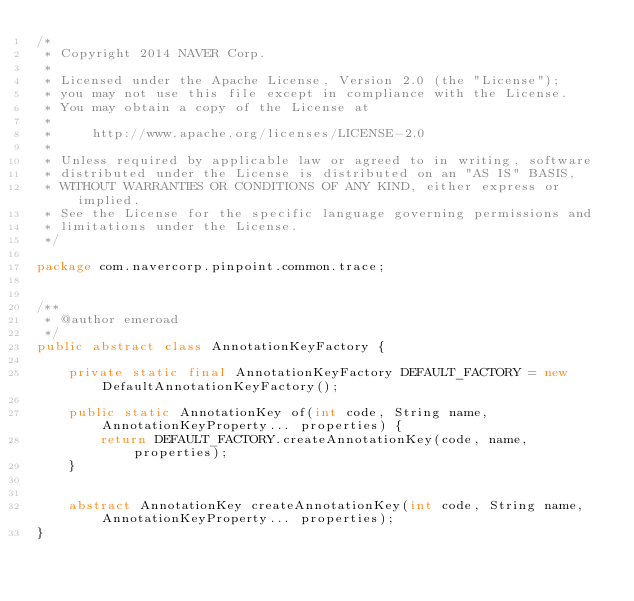Convert code to text. <code><loc_0><loc_0><loc_500><loc_500><_Java_>/*
 * Copyright 2014 NAVER Corp.
 *
 * Licensed under the Apache License, Version 2.0 (the "License");
 * you may not use this file except in compliance with the License.
 * You may obtain a copy of the License at
 *
 *     http://www.apache.org/licenses/LICENSE-2.0
 *
 * Unless required by applicable law or agreed to in writing, software
 * distributed under the License is distributed on an "AS IS" BASIS,
 * WITHOUT WARRANTIES OR CONDITIONS OF ANY KIND, either express or implied.
 * See the License for the specific language governing permissions and
 * limitations under the License.
 */

package com.navercorp.pinpoint.common.trace;


/**
 * @author emeroad
 */
public abstract class AnnotationKeyFactory {

    private static final AnnotationKeyFactory DEFAULT_FACTORY = new DefaultAnnotationKeyFactory();

    public static AnnotationKey of(int code, String name, AnnotationKeyProperty... properties) {
        return DEFAULT_FACTORY.createAnnotationKey(code, name, properties);
    }


    abstract AnnotationKey createAnnotationKey(int code, String name, AnnotationKeyProperty... properties);
}</code> 